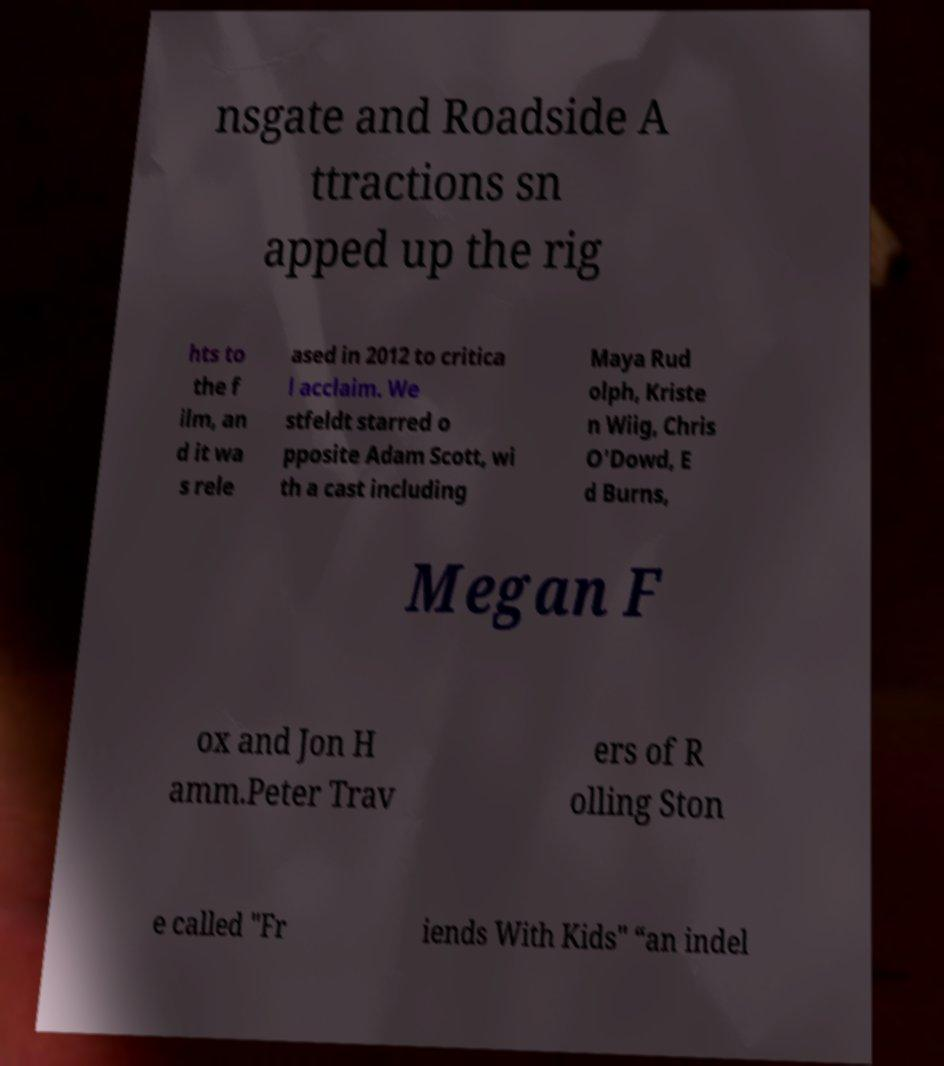Please identify and transcribe the text found in this image. nsgate and Roadside A ttractions sn apped up the rig hts to the f ilm, an d it wa s rele ased in 2012 to critica l acclaim. We stfeldt starred o pposite Adam Scott, wi th a cast including Maya Rud olph, Kriste n Wiig, Chris O'Dowd, E d Burns, Megan F ox and Jon H amm.Peter Trav ers of R olling Ston e called "Fr iends With Kids" “an indel 